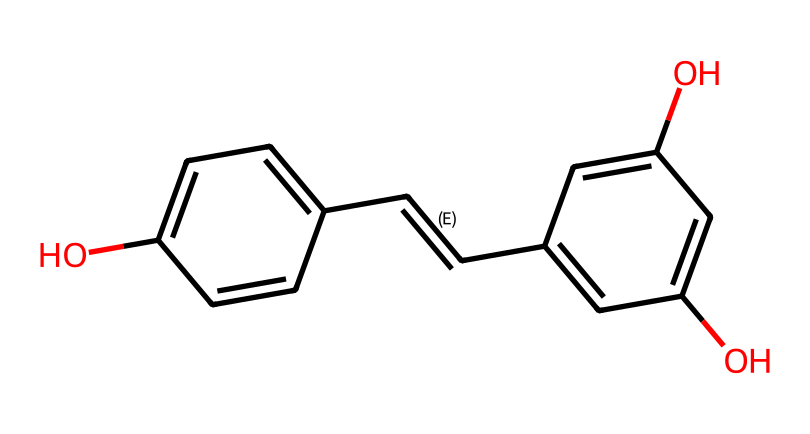What is the chemical name of this structure? The SMILES representation corresponds to resveratrol, which has a well-known chemical name associated with its antioxidant properties.
Answer: resveratrol How many hydroxyl groups are present in this compound? By analyzing the structure, we can identify two -OH (hydroxyl) groups attached to the aromatic rings, indicating that there are two hydroxyl groups.
Answer: two What type of bonds are present between the carbon atoms? The structure displays both single (sigma) bonds and one double bond (indicating a C=C bond) between the carbon atoms, contributing to its unsaturation.
Answer: single and double What is the molecular formula of resveratrol? Considering the count of carbon, hydrogen, and oxygen from the structure, the molecular formula can be derived as C14H12O3.
Answer: C14H12O3 How do the hydroxyl groups influence the antioxidant properties of resveratrol? The presence of the hydroxyl groups increases the compound's ability to donate electrons or hydrogen atoms, which is crucial for the antioxidant activity by neutralizing free radicals.
Answer: increases antioxidant activity What is the significance of the trans configuration in resveratrol? The trans double bond configuration in the compound contributes to its stability and biological activity compared to the cis form, which is less stable.
Answer: stability and biological activity In what type of beverages is resveratrol commonly found? Resveratrol is primarily found in red wine due to the fermentation process of grapes, which enhances its concentration in the final product.
Answer: red wine 